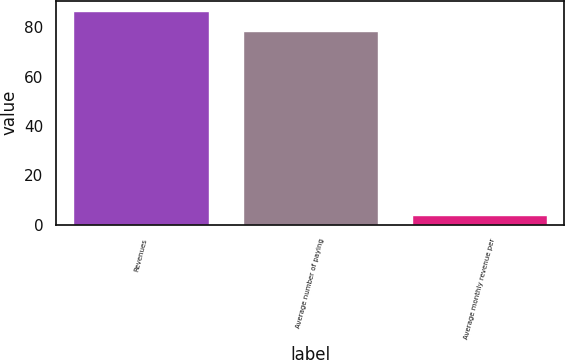Convert chart to OTSL. <chart><loc_0><loc_0><loc_500><loc_500><bar_chart><fcel>Revenues<fcel>Average number of paying<fcel>Average monthly revenue per<nl><fcel>86.43<fcel>78.3<fcel>3.8<nl></chart> 